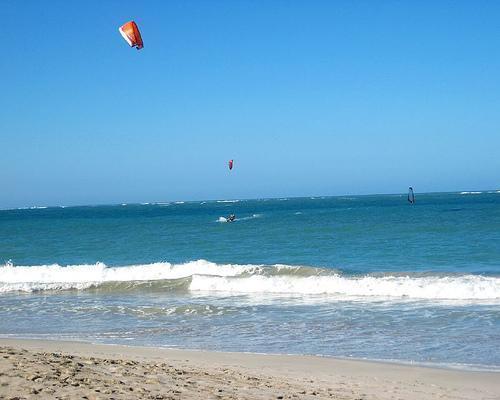To what is this sail attached?
Indicate the correct response and explain using: 'Answer: answer
Rationale: rationale.'
Options: Nothing, shark, beach comber, surfer. Answer: surfer.
Rationale: The sail is on the surfer. 